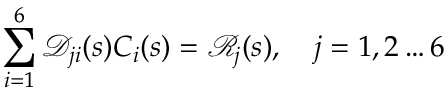<formula> <loc_0><loc_0><loc_500><loc_500>\sum _ { i = 1 } ^ { 6 } \ m a t h s c r { D } _ { j i } ( s ) C _ { i } ( s ) = \ m a t h s c r { R } _ { j } ( s ) , \quad j = 1 , 2 \dots 6</formula> 